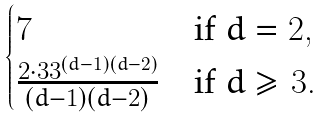<formula> <loc_0><loc_0><loc_500><loc_500>\begin{cases} 7 & \text {if } d = 2 , \\ \frac { 2 \cdot 3 3 ^ { ( d - 1 ) ( d - 2 ) } } { ( d - 1 ) ( d - 2 ) } & \text {if } d \geq 3 . \end{cases}</formula> 